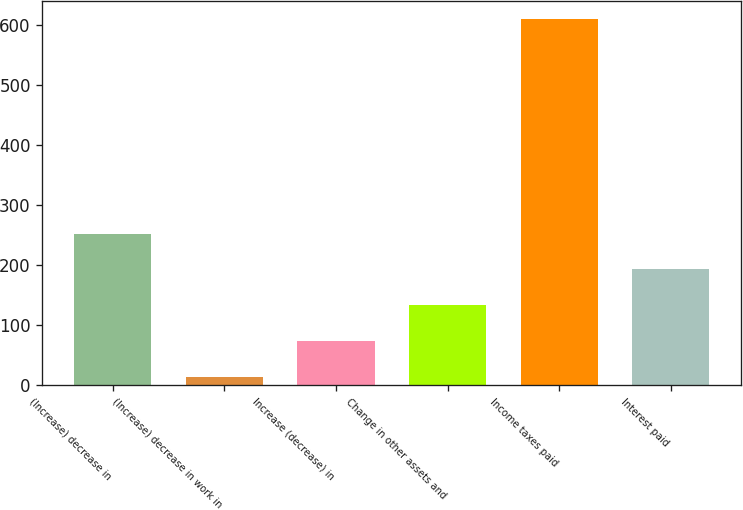<chart> <loc_0><loc_0><loc_500><loc_500><bar_chart><fcel>(Increase) decrease in<fcel>(Increase) decrease in work in<fcel>Increase (decrease) in<fcel>Change in other assets and<fcel>Income taxes paid<fcel>Interest paid<nl><fcel>252.56<fcel>14.2<fcel>73.79<fcel>133.38<fcel>610.1<fcel>192.97<nl></chart> 